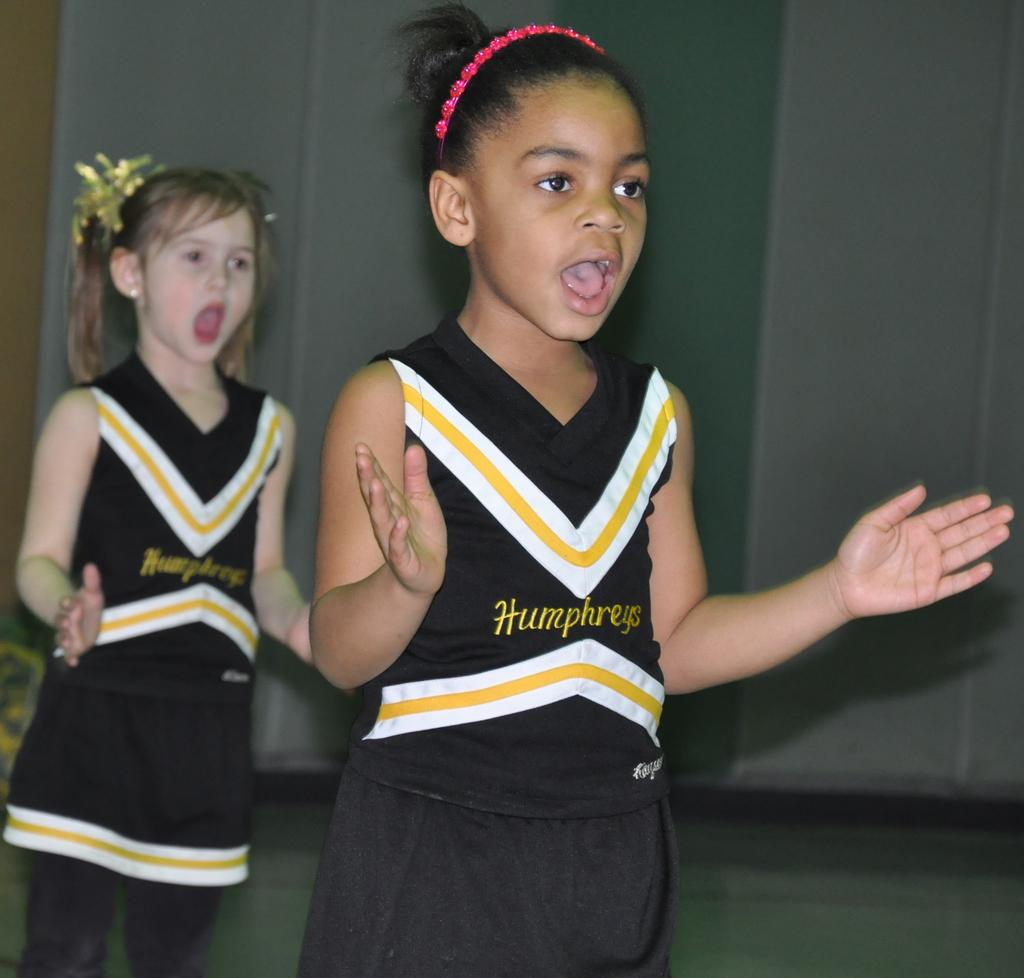<image>
Share a concise interpretation of the image provided. The girls are doing a cheer for their school named Humphreys. 